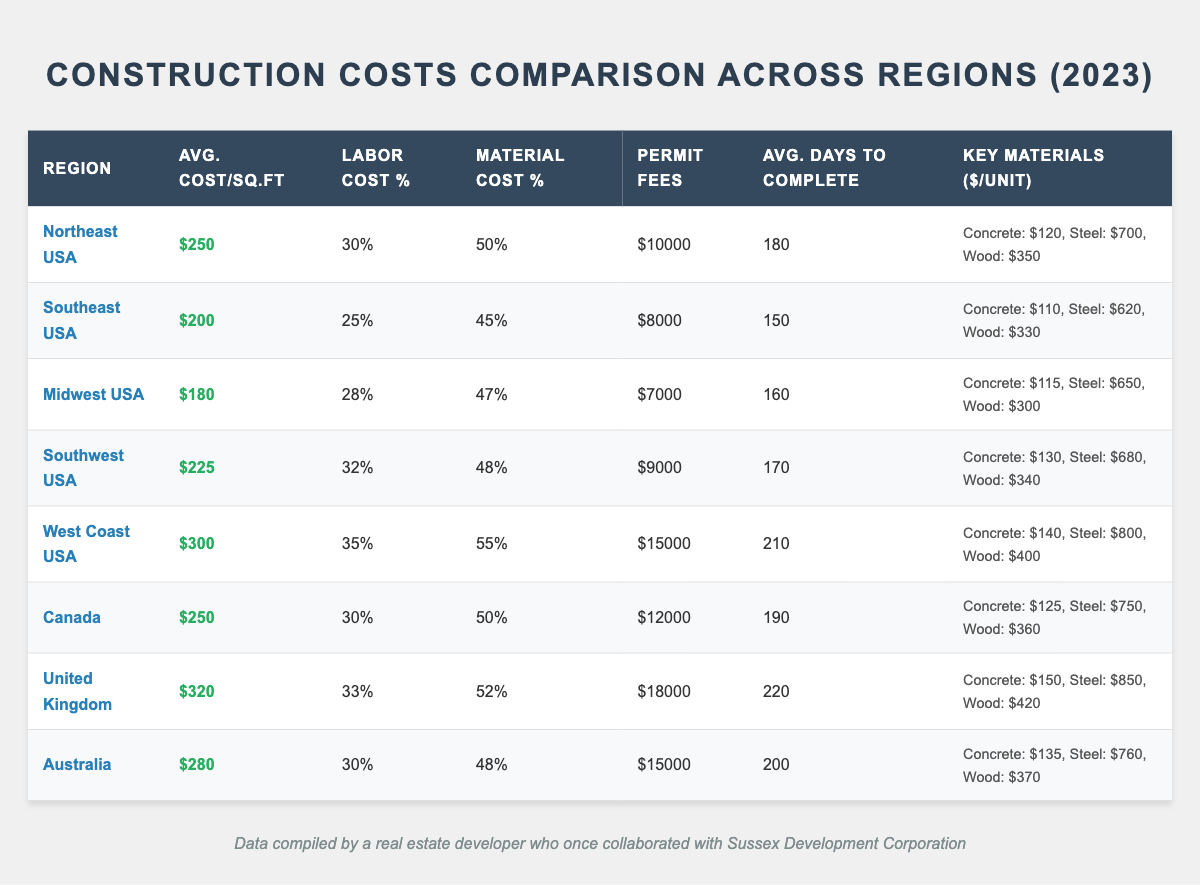What's the average cost per square foot in the Midwest USA? The table shows that the average cost per square foot for the Midwest USA region is listed as 180.
Answer: 180 Which region has the highest labor cost percentage? By inspecting the table, the West Coast USA has the highest labor cost percentage at 35%.
Answer: West Coast USA What is the average number of days to complete a construction project in Canada? According to the table, the average days to completion for Canada is 190 days.
Answer: 190 days Which region has the lowest permit fees? Upon examining the permit fees listed, the Midwest USA has the lowest permit fees at $7,000.
Answer: Midwest USA How does the average cost per square foot of the Northeast compare to the Southeast USA? The table shows that the Northeast USA has an average cost of $250 per square foot, while the Southeast USA has $200. The difference is $50.
Answer: $50 What percentage of the total construction cost in the United Kingdom is attributed to labor? In the United Kingdom, the labor cost percentage is 33%, which indicates that one-third of the total construction cost goes to labor.
Answer: 33% What is the average cost per square foot across all regions listed? First, sum the average costs per square foot for each region: 250 + 200 + 180 + 225 + 300 + 250 + 320 + 280 = 2005. Dividing by 8 regions provides the average cost per square foot: 2005/8 = 250.625.
Answer: 250.625 Is the material cost percentage higher in Australia than in the Midwest USA? The material cost percentage in Australia is 48%, while the percentage for the Midwest USA is 47%. Therefore, it is higher in Australia.
Answer: Yes Which region requires the longest average days for project completion, and what is that duration? The United Kingdom has the longest average days to completion at 220 days based on the table values.
Answer: 220 days What is the total permit fees for all regions combined? To find total permit fees, add the permit fees for each region: 10,000 + 8,000 + 7,000 + 9,000 + 15,000 + 12,000 + 18,000 + 15,000 = 94,000.
Answer: $94,000 Does Canada have a higher average cost per square foot than the Midwest USA? Canada has an average cost per square foot of $250, which is higher than the Midwest USA's cost of $180.
Answer: Yes 